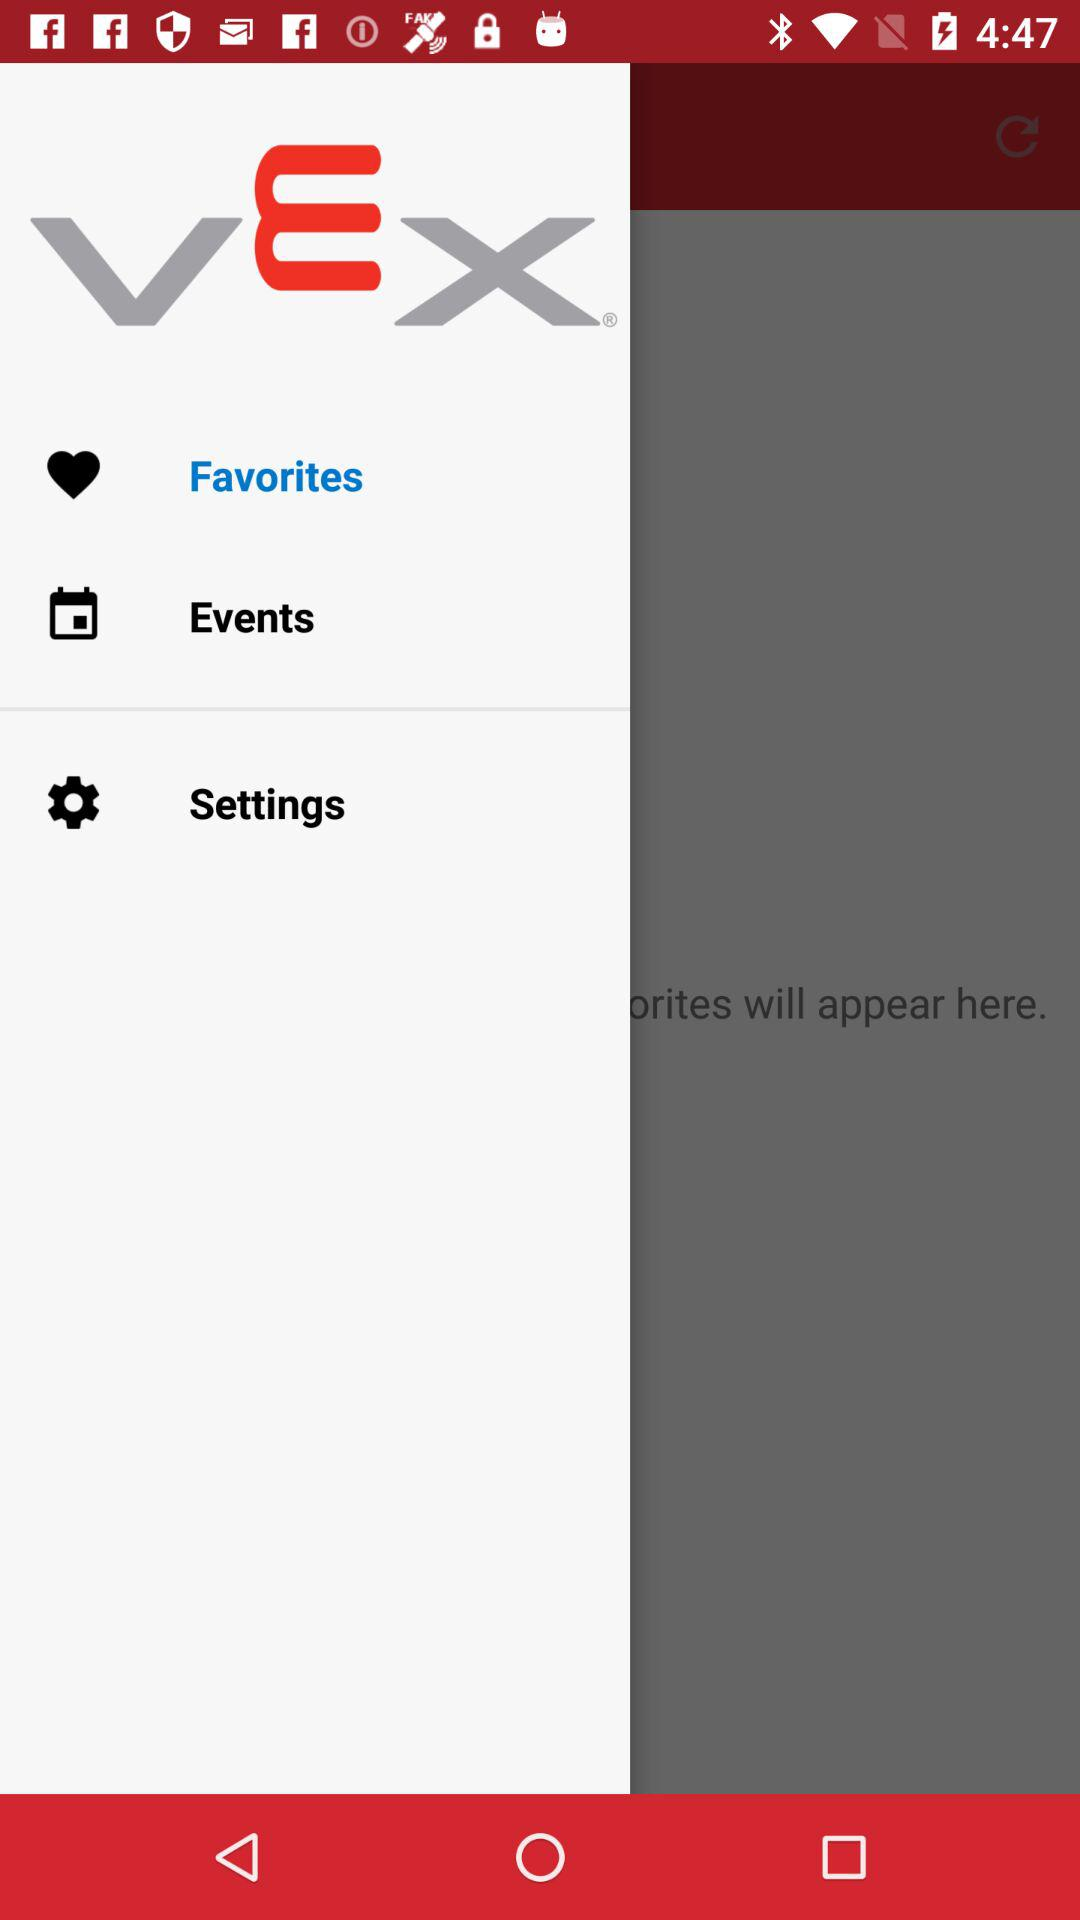When is the next event?
When the provided information is insufficient, respond with <no answer>. <no answer> 